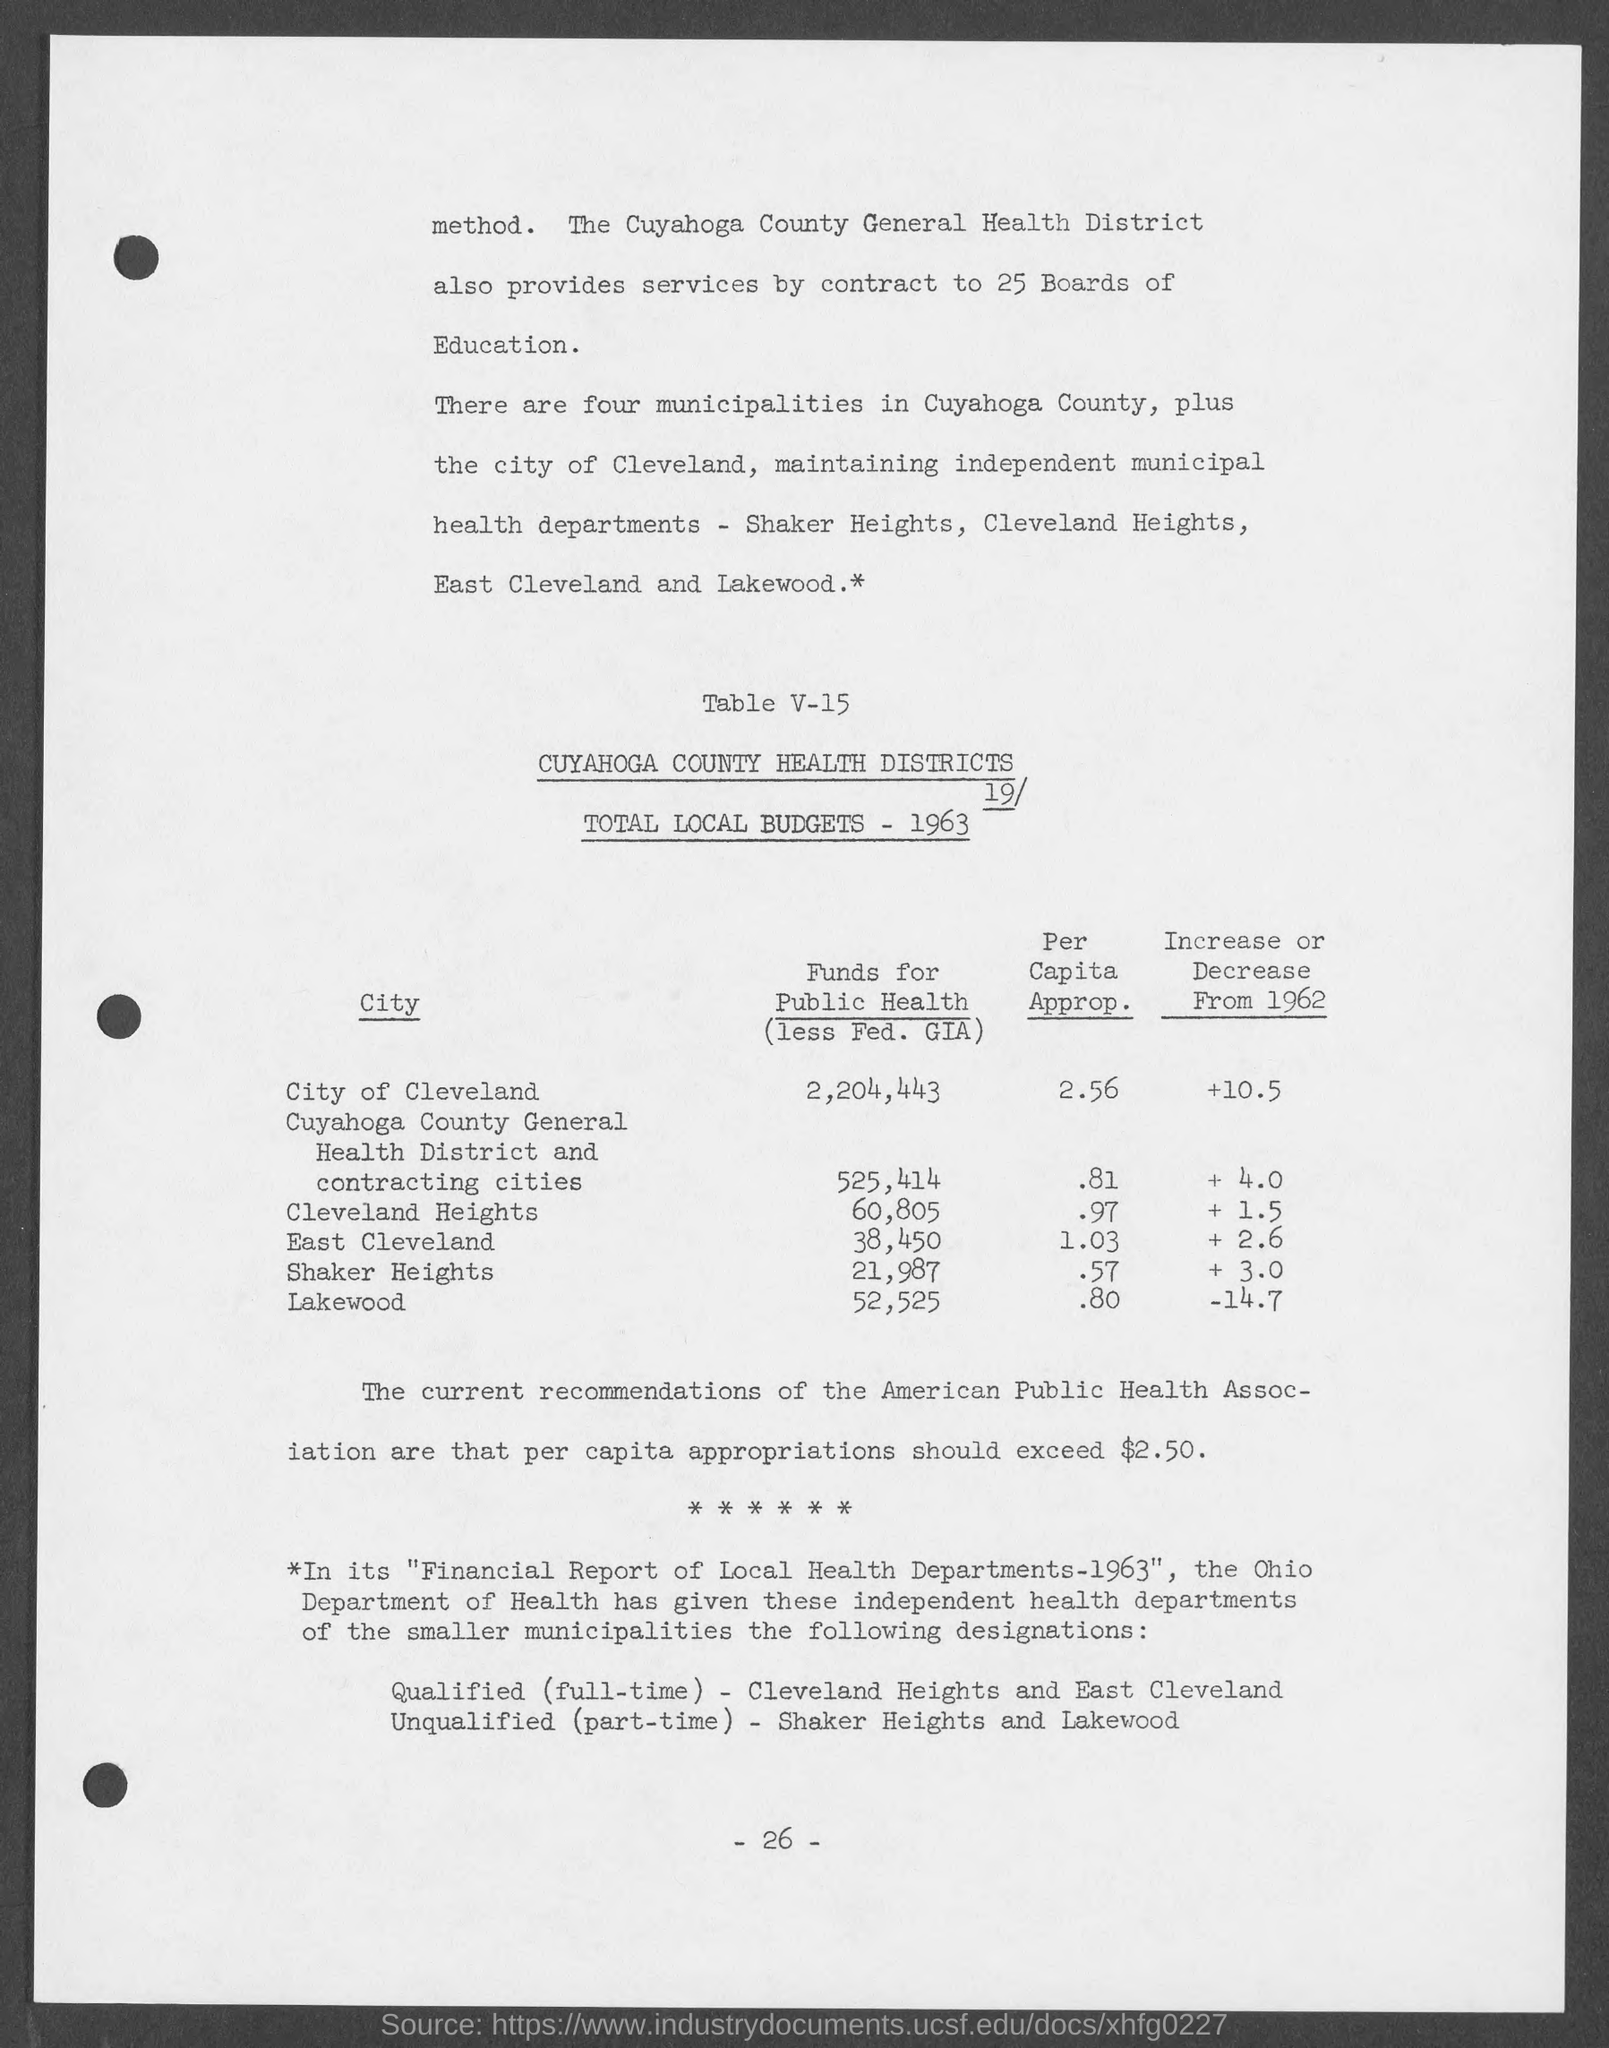To how manay boards of education does the cuyhoga county general health provides service?
Offer a very short reply. 25. How many municipalities are there in cuyahoga county?
Offer a very short reply. Four. Total local budgets is for which year?
Keep it short and to the point. 1963. How much is the per capita approp. for city of cleveland?
Make the answer very short. 2.56. How much is the funds for the public health for lakewood?
Offer a very short reply. 52,525. Which department  has given designations for independent health department of smaller municipalities?
Ensure brevity in your answer.  The ohio department of health. 